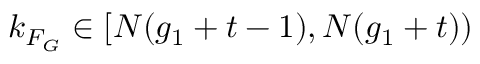<formula> <loc_0><loc_0><loc_500><loc_500>k _ { F _ { G } } \in [ N ( g _ { 1 } + t - 1 ) , N ( g _ { 1 } + t ) )</formula> 